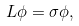<formula> <loc_0><loc_0><loc_500><loc_500>L \phi = \sigma \phi ,</formula> 